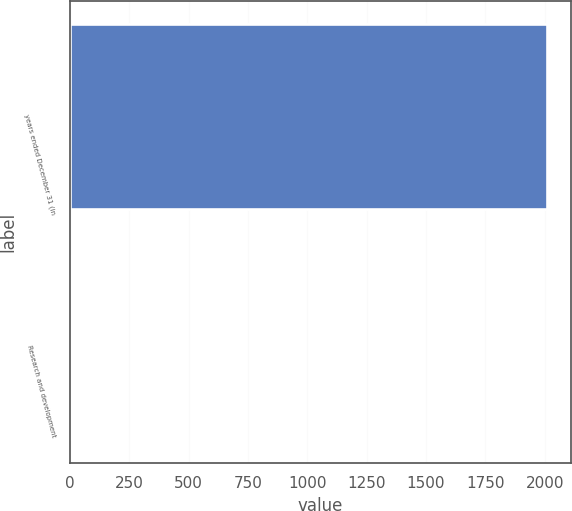Convert chart. <chart><loc_0><loc_0><loc_500><loc_500><bar_chart><fcel>years ended December 31 (in<fcel>Research and development<nl><fcel>2011<fcel>5<nl></chart> 